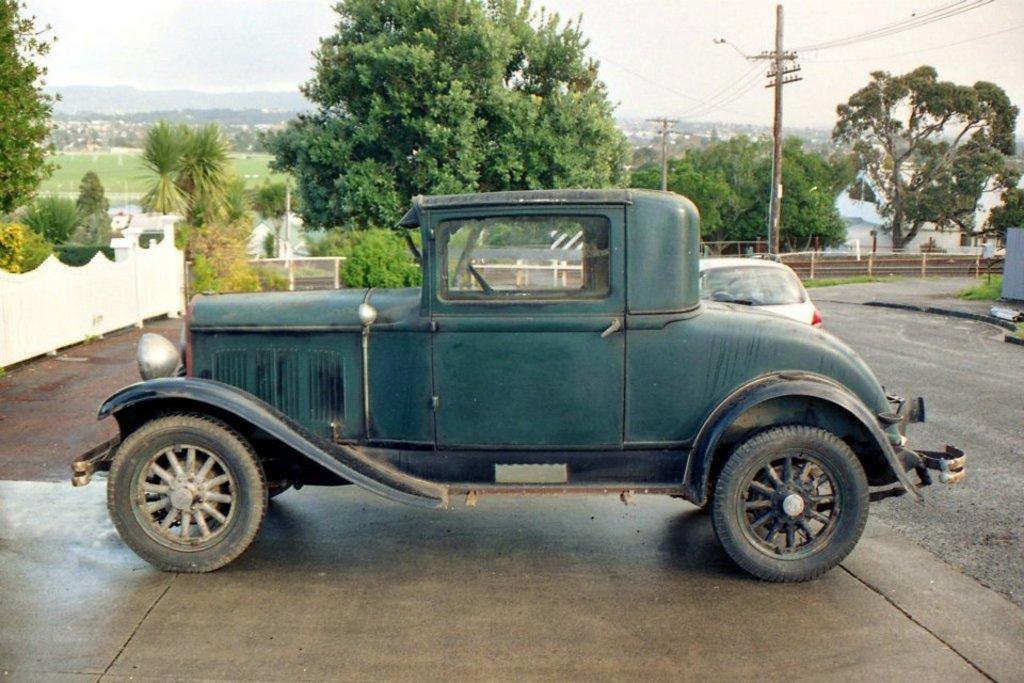In one or two sentences, can you explain what this image depicts? In this image we can see cars on the road. In the background of the image there are trees, electric poles, wires, sky. To the left side of the image there is a fencing. At the bottom of the image there is road. 